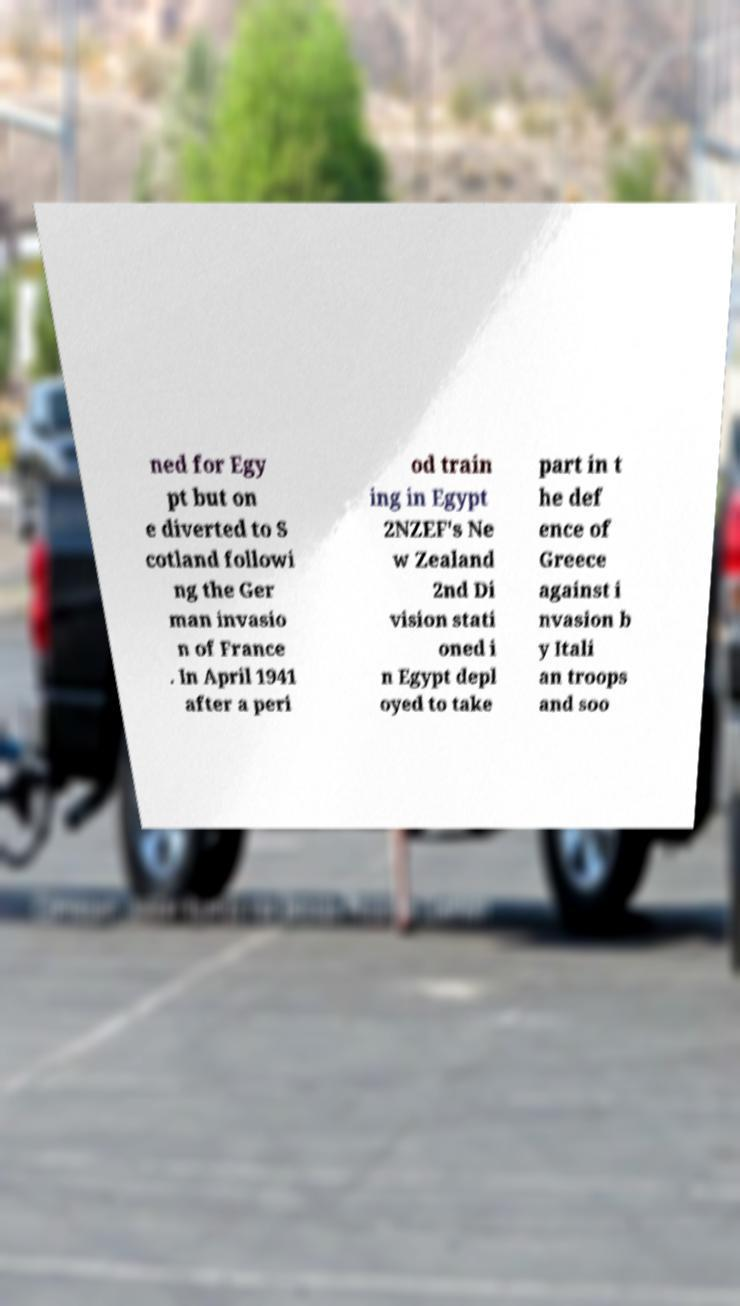Could you extract and type out the text from this image? ned for Egy pt but on e diverted to S cotland followi ng the Ger man invasio n of France . In April 1941 after a peri od train ing in Egypt 2NZEF's Ne w Zealand 2nd Di vision stati oned i n Egypt depl oyed to take part in t he def ence of Greece against i nvasion b y Itali an troops and soo 